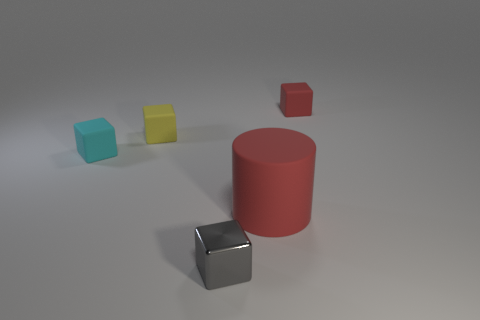Add 4 tiny gray objects. How many objects exist? 9 Subtract all blocks. How many objects are left? 1 Subtract all large gray rubber cylinders. Subtract all gray metallic objects. How many objects are left? 4 Add 1 tiny blocks. How many tiny blocks are left? 5 Add 1 gray metallic cubes. How many gray metallic cubes exist? 2 Subtract 1 red blocks. How many objects are left? 4 